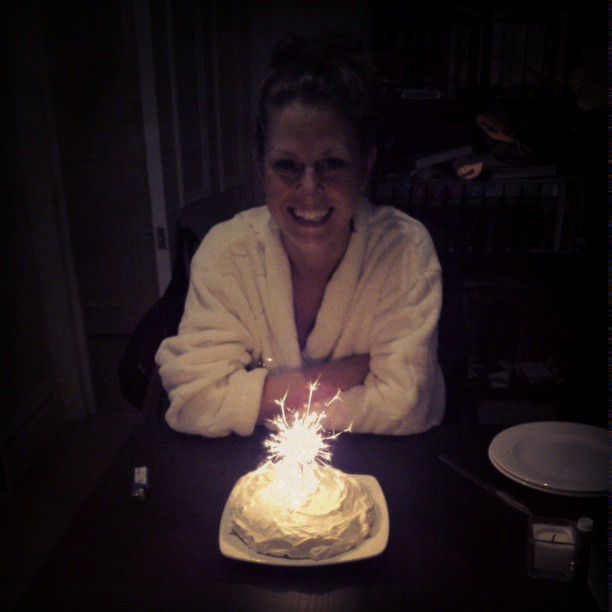How old is the birthday person? The person celebrating her birthday appears to be enjoying the occasion radiantly. Her age might be guessed as somewhere in her middle to late thirties based on typical visual indicators. 